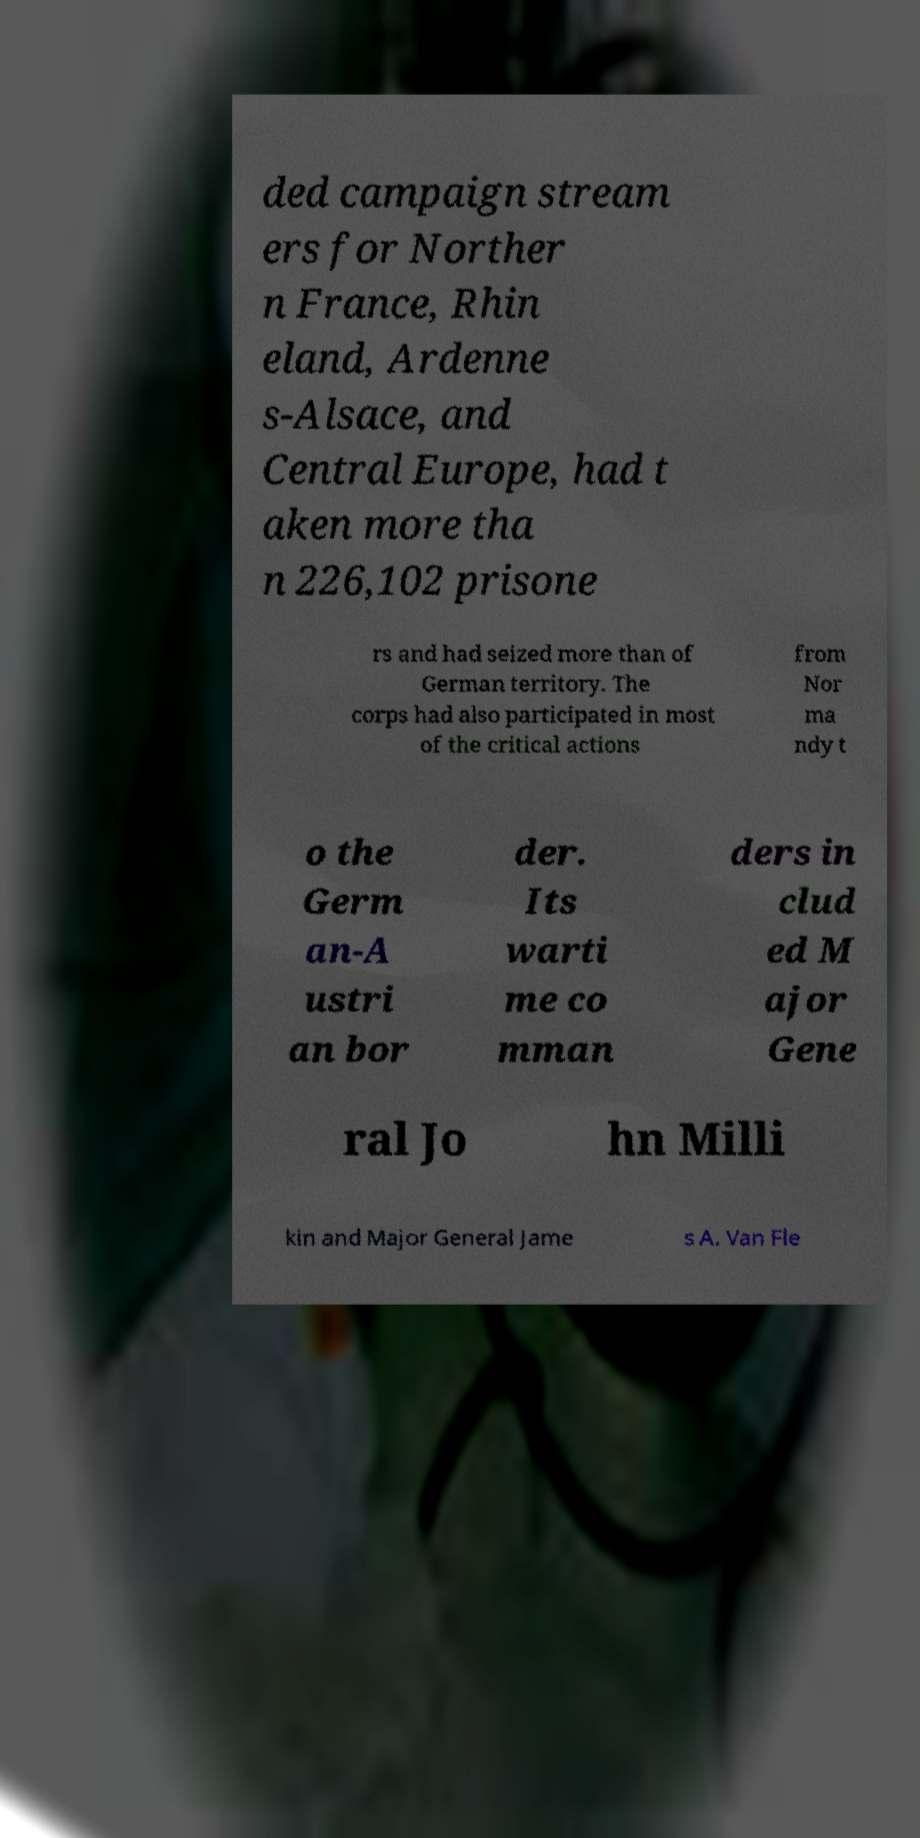Please identify and transcribe the text found in this image. ded campaign stream ers for Norther n France, Rhin eland, Ardenne s-Alsace, and Central Europe, had t aken more tha n 226,102 prisone rs and had seized more than of German territory. The corps had also participated in most of the critical actions from Nor ma ndy t o the Germ an-A ustri an bor der. Its warti me co mman ders in clud ed M ajor Gene ral Jo hn Milli kin and Major General Jame s A. Van Fle 